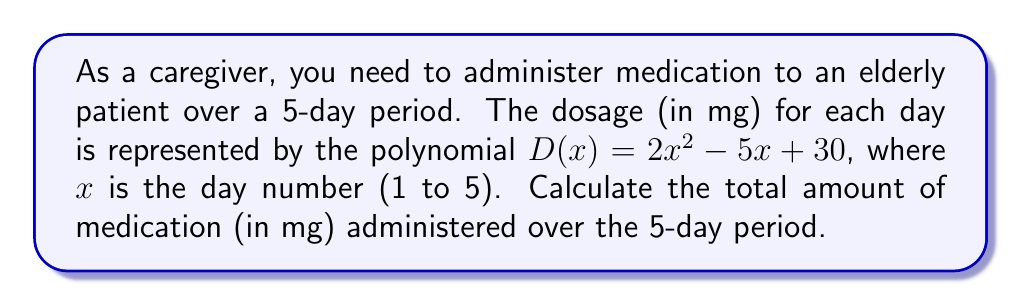What is the answer to this math problem? To solve this problem, we need to follow these steps:

1) The dosage for each day is given by the polynomial $D(x) = 2x^2 - 5x + 30$

2) We need to calculate the dosage for each day (x = 1, 2, 3, 4, 5) and then sum these values:

   Day 1 (x = 1): $D(1) = 2(1)^2 - 5(1) + 30 = 2 - 5 + 30 = 27$ mg
   Day 2 (x = 2): $D(2) = 2(2)^2 - 5(2) + 30 = 8 - 10 + 30 = 28$ mg
   Day 3 (x = 3): $D(3) = 2(3)^2 - 5(3) + 30 = 18 - 15 + 30 = 33$ mg
   Day 4 (x = 4): $D(4) = 2(4)^2 - 5(4) + 30 = 32 - 20 + 30 = 42$ mg
   Day 5 (x = 5): $D(5) = 2(5)^2 - 5(5) + 30 = 50 - 25 + 30 = 55$ mg

3) Now, we sum all these dosages:

   Total dosage = 27 + 28 + 33 + 42 + 55 = 185 mg

Therefore, the total amount of medication administered over the 5-day period is 185 mg.
Answer: 185 mg 